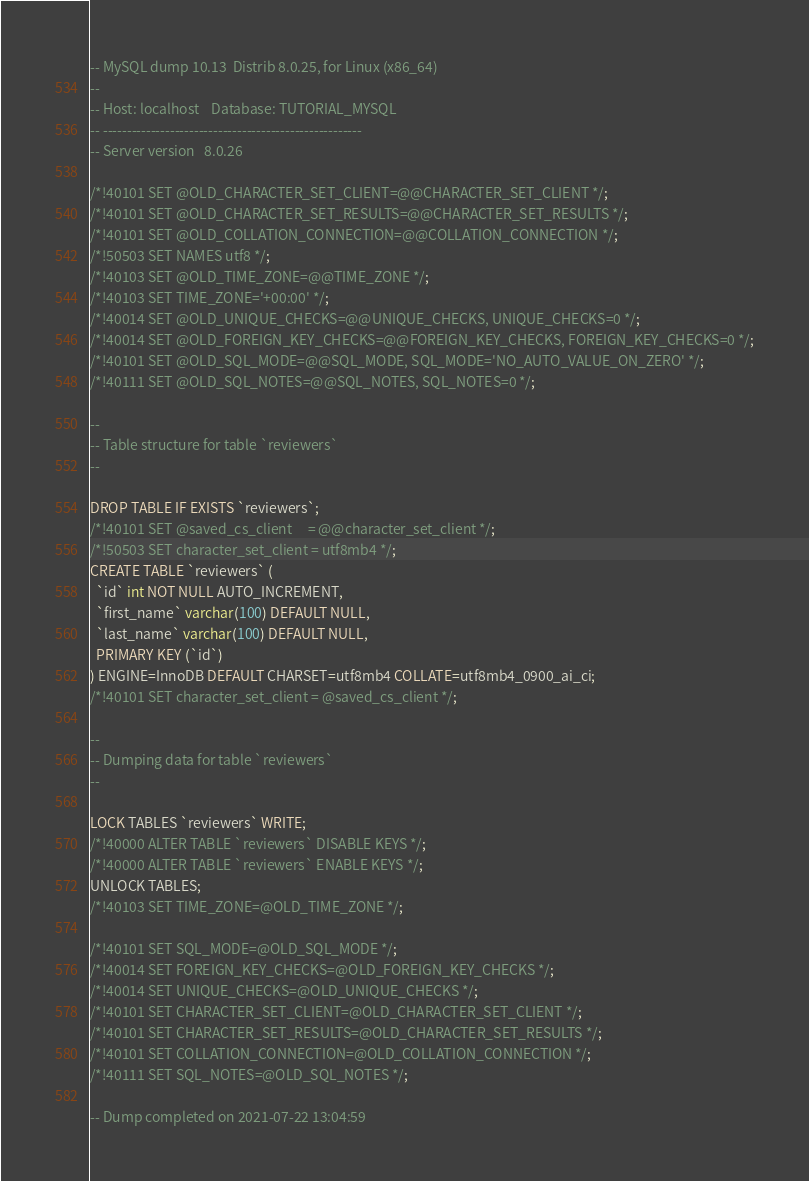Convert code to text. <code><loc_0><loc_0><loc_500><loc_500><_SQL_>-- MySQL dump 10.13  Distrib 8.0.25, for Linux (x86_64)
--
-- Host: localhost    Database: TUTORIAL_MYSQL
-- ------------------------------------------------------
-- Server version	8.0.26

/*!40101 SET @OLD_CHARACTER_SET_CLIENT=@@CHARACTER_SET_CLIENT */;
/*!40101 SET @OLD_CHARACTER_SET_RESULTS=@@CHARACTER_SET_RESULTS */;
/*!40101 SET @OLD_COLLATION_CONNECTION=@@COLLATION_CONNECTION */;
/*!50503 SET NAMES utf8 */;
/*!40103 SET @OLD_TIME_ZONE=@@TIME_ZONE */;
/*!40103 SET TIME_ZONE='+00:00' */;
/*!40014 SET @OLD_UNIQUE_CHECKS=@@UNIQUE_CHECKS, UNIQUE_CHECKS=0 */;
/*!40014 SET @OLD_FOREIGN_KEY_CHECKS=@@FOREIGN_KEY_CHECKS, FOREIGN_KEY_CHECKS=0 */;
/*!40101 SET @OLD_SQL_MODE=@@SQL_MODE, SQL_MODE='NO_AUTO_VALUE_ON_ZERO' */;
/*!40111 SET @OLD_SQL_NOTES=@@SQL_NOTES, SQL_NOTES=0 */;

--
-- Table structure for table `reviewers`
--

DROP TABLE IF EXISTS `reviewers`;
/*!40101 SET @saved_cs_client     = @@character_set_client */;
/*!50503 SET character_set_client = utf8mb4 */;
CREATE TABLE `reviewers` (
  `id` int NOT NULL AUTO_INCREMENT,
  `first_name` varchar(100) DEFAULT NULL,
  `last_name` varchar(100) DEFAULT NULL,
  PRIMARY KEY (`id`)
) ENGINE=InnoDB DEFAULT CHARSET=utf8mb4 COLLATE=utf8mb4_0900_ai_ci;
/*!40101 SET character_set_client = @saved_cs_client */;

--
-- Dumping data for table `reviewers`
--

LOCK TABLES `reviewers` WRITE;
/*!40000 ALTER TABLE `reviewers` DISABLE KEYS */;
/*!40000 ALTER TABLE `reviewers` ENABLE KEYS */;
UNLOCK TABLES;
/*!40103 SET TIME_ZONE=@OLD_TIME_ZONE */;

/*!40101 SET SQL_MODE=@OLD_SQL_MODE */;
/*!40014 SET FOREIGN_KEY_CHECKS=@OLD_FOREIGN_KEY_CHECKS */;
/*!40014 SET UNIQUE_CHECKS=@OLD_UNIQUE_CHECKS */;
/*!40101 SET CHARACTER_SET_CLIENT=@OLD_CHARACTER_SET_CLIENT */;
/*!40101 SET CHARACTER_SET_RESULTS=@OLD_CHARACTER_SET_RESULTS */;
/*!40101 SET COLLATION_CONNECTION=@OLD_COLLATION_CONNECTION */;
/*!40111 SET SQL_NOTES=@OLD_SQL_NOTES */;

-- Dump completed on 2021-07-22 13:04:59
</code> 